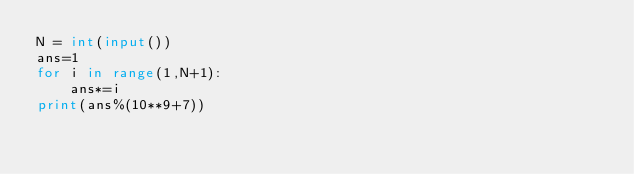Convert code to text. <code><loc_0><loc_0><loc_500><loc_500><_Python_>N = int(input())
ans=1
for i in range(1,N+1):
    ans*=i
print(ans%(10**9+7))</code> 